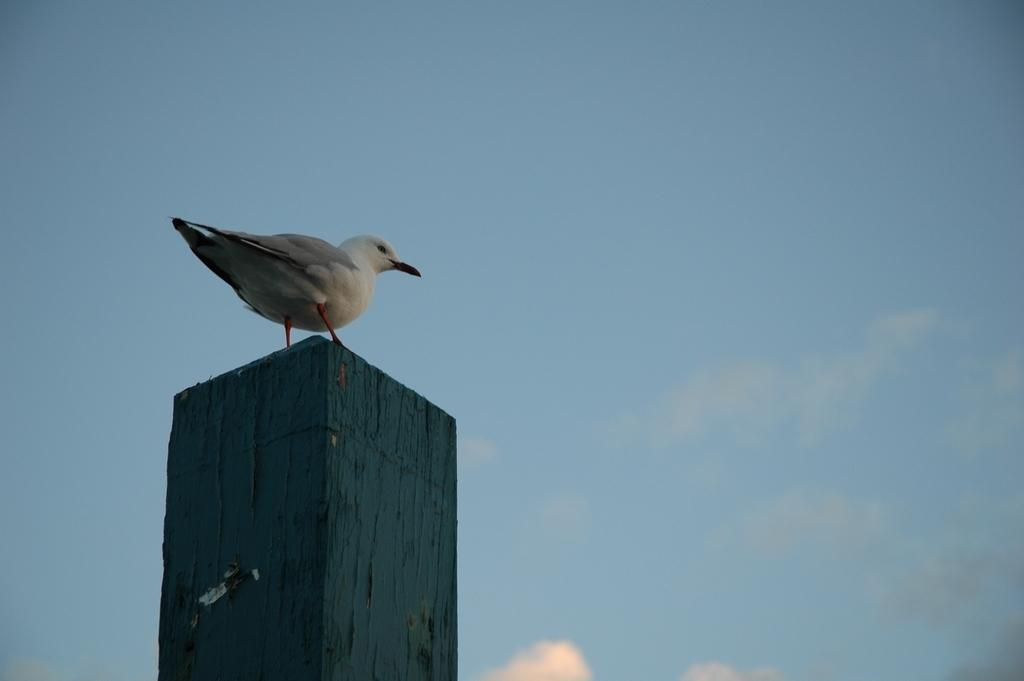What type of animal is in the image? There is a bird in the image. Where is the bird located? The bird is on a pillar. What can be seen in the background of the image? There is sky visible in the background of the image. What type of meeting is taking place between the giants in the image? There are no giants present in the image, so it is not possible to discuss a meeting between them. 